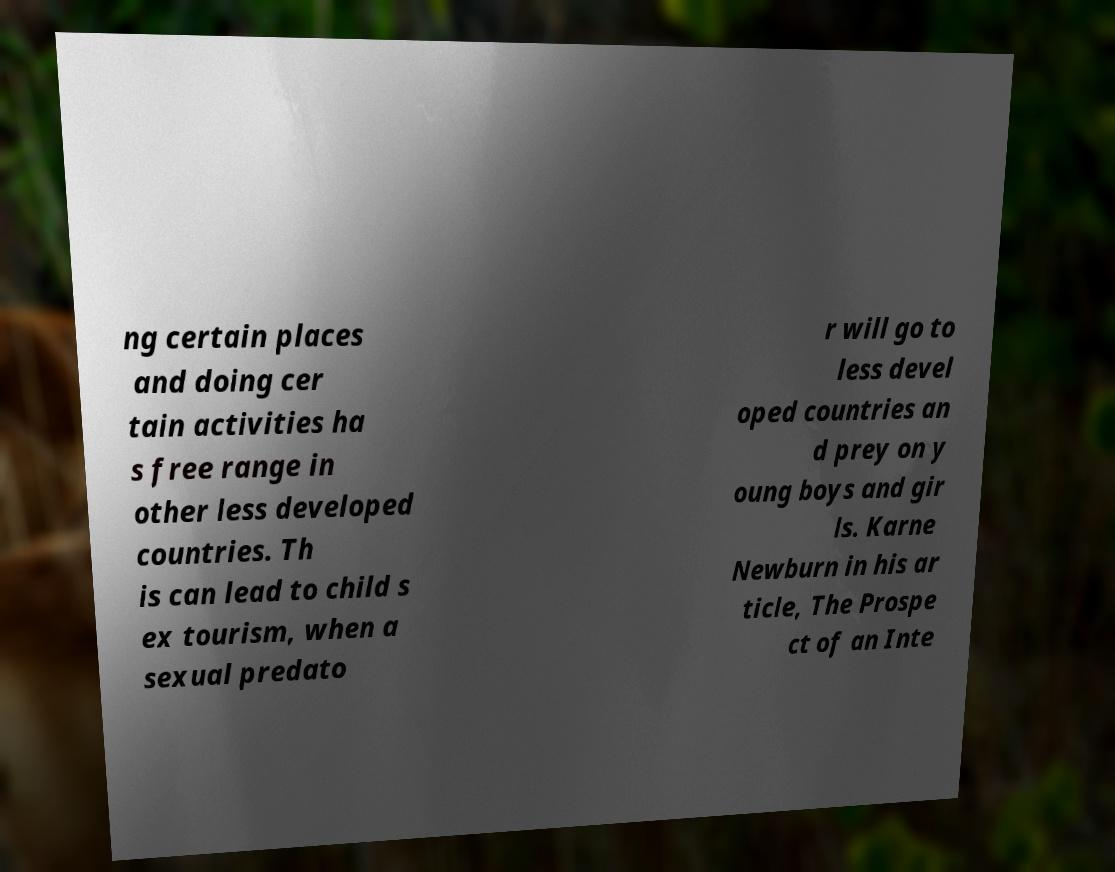Please read and relay the text visible in this image. What does it say? ng certain places and doing cer tain activities ha s free range in other less developed countries. Th is can lead to child s ex tourism, when a sexual predato r will go to less devel oped countries an d prey on y oung boys and gir ls. Karne Newburn in his ar ticle, The Prospe ct of an Inte 